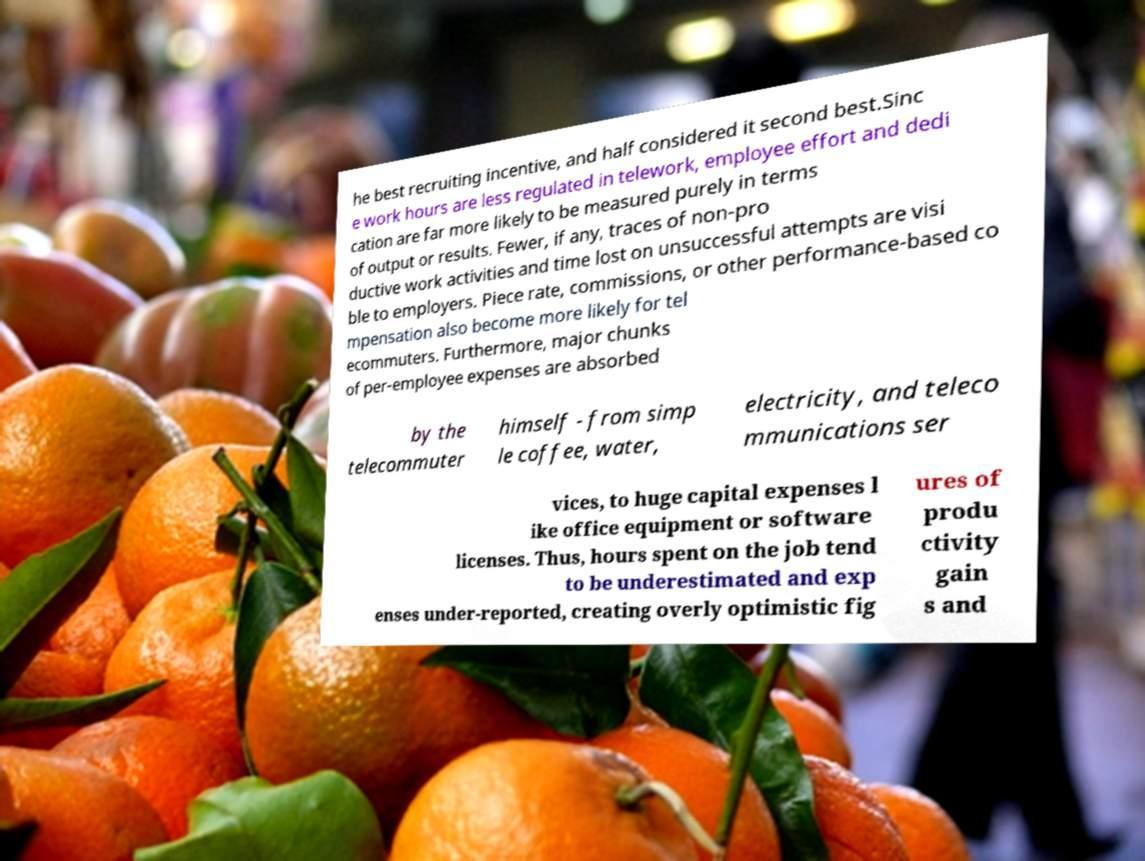Please identify and transcribe the text found in this image. he best recruiting incentive, and half considered it second best.Sinc e work hours are less regulated in telework, employee effort and dedi cation are far more likely to be measured purely in terms of output or results. Fewer, if any, traces of non-pro ductive work activities and time lost on unsuccessful attempts are visi ble to employers. Piece rate, commissions, or other performance-based co mpensation also become more likely for tel ecommuters. Furthermore, major chunks of per-employee expenses are absorbed by the telecommuter himself - from simp le coffee, water, electricity, and teleco mmunications ser vices, to huge capital expenses l ike office equipment or software licenses. Thus, hours spent on the job tend to be underestimated and exp enses under-reported, creating overly optimistic fig ures of produ ctivity gain s and 